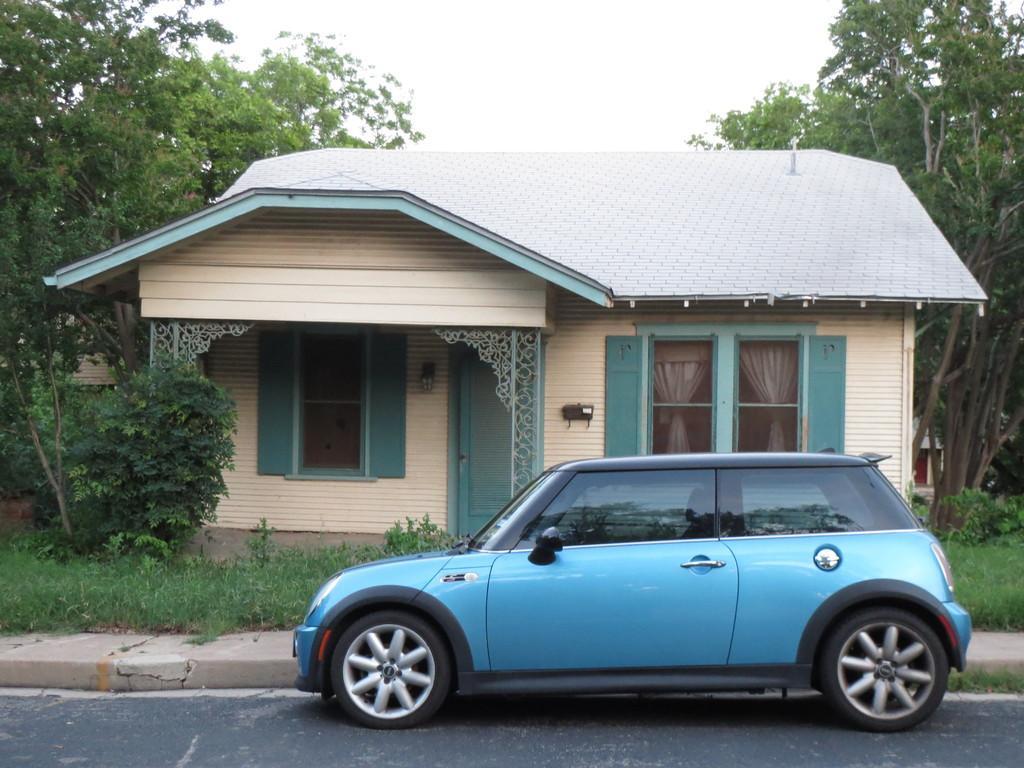Can you describe this image briefly? In this image we can see the car. And we can see the road. And we can see the grass. And we can see the house. And we can see the trees. And we can see the sky. 